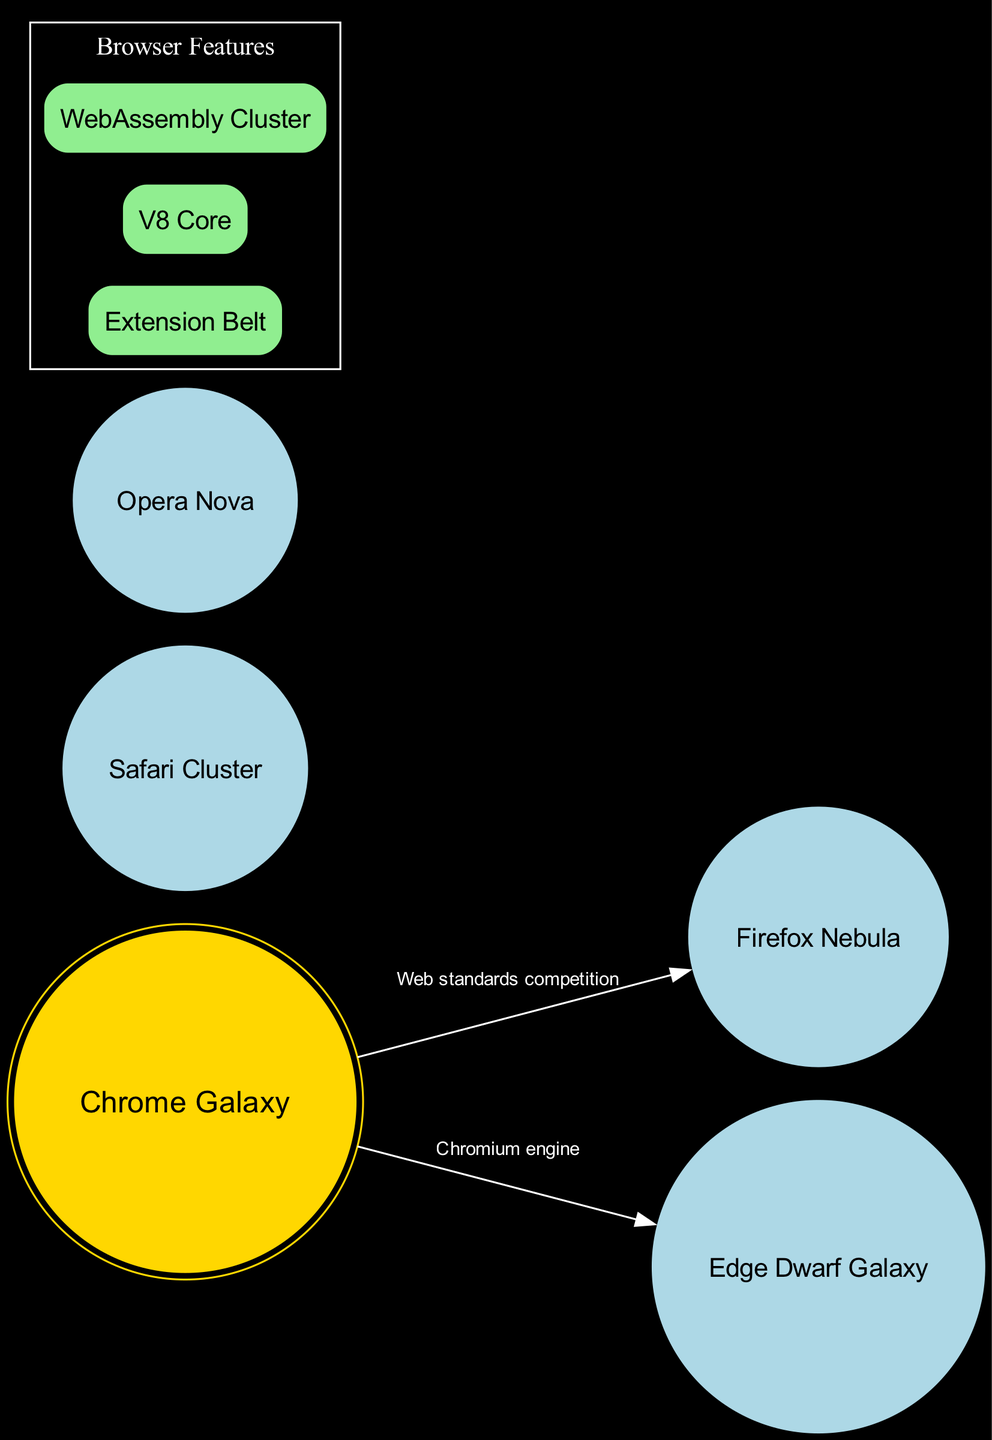What is the name of the central galaxy? The diagram depicts Chrome as the central galaxy. The center is specifically labeled "Chrome Galaxy."
Answer: Chrome Galaxy How many orbiting galaxies are depicted? The diagram lists four orbiting galaxies around the central galaxy. These galaxies can be counted in the orbiting_galaxies section.
Answer: Four What is the connection label between Chrome Galaxy and Edge Dwarf Galaxy? The connection between Chrome Galaxy and Edge Dwarf Galaxy indicates that they are linked via the "Chromium engine." This label is directly mentioned in the connections section.
Answer: Chromium engine Which galaxy is described as the "Open-source browser cluster"? The diagram provides descriptions for the orbiting galaxies, stating that Firefox Nebula is the one described as the "Open-source browser cluster."
Answer: Firefox Nebula What feature is associated with high-performance JavaScript? Among the features listed in the diagram, "V8 Core" is specifically noted as the feature associated with high-performance JavaScript, which can be found in the features section.
Answer: V8 Core Which browser is described as "Apple's browser constellation"? The description "Apple's browser constellation" refers to the "Safari Cluster," which can be identified in the orbiting_galaxies section of the diagram.
Answer: Safari Cluster Which feature provides a rich ecosystem of browser add-ons? The diagram mentions "Extension Belt" as the feature that provides a rich ecosystem for browser add-ons, indicating its unique significance in the features section.
Answer: Extension Belt What is the relationship between Chrome Galaxy and Firefox Nebula? The relationship is characterized as "Web standards competition," demonstrated by the arrow labeled with this description between the two galaxies in the connections section of the diagram.
Answer: Web standards competition What color is the Chrome Galaxy depicted in? The Chrome Galaxy is represented with a gold color in the diagram, which is highlighted in the node attributes for the center galaxy.
Answer: Gold 